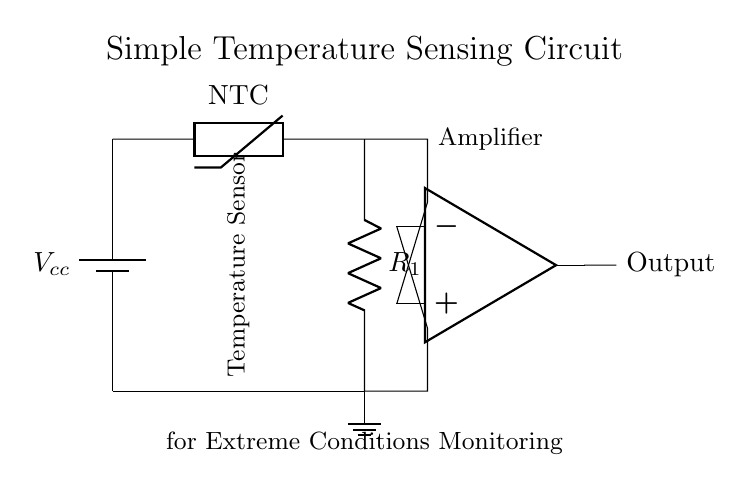What type of temperature sensor is used in this circuit? The circuit uses an NTC thermistor as the temperature sensor, indicated by the label on the component within the diagram.
Answer: NTC thermistor What does the op-amp do in this circuit? The operational amplifier (op-amp) amplifies the voltage difference between its input terminals, providing a stronger output signal that corresponds to the temperature reading.
Answer: Amplifies signal What is the configuration of the thermistor with the resistor in this circuit? The thermistor is configured in a voltage divider arrangement with the resistor, which allows for a change in voltage output relative to temperature changes detected by the thermistor.
Answer: Voltage divider What is the purpose of the battery in this circuit? The battery provides the necessary voltage supply for the circuit components, ensuring they operate correctly during temperature sensing.
Answer: Power supply What happens to the output as the temperature increases? As the temperature increases, the resistance of the NTC thermistor decreases, resulting in a higher voltage at the op-amp input, leading to a higher output voltage.
Answer: Output increases What is the connection between the thermistor and the op-amp in this circuit? The thermistor is connected directly to the non-inverting input of the op-amp, providing a voltage signal that corresponds to the measured temperature, while the resistor provides a reference voltage at the inverting input.
Answer: Connected to op-amp inputs How many main components are present in the circuit? The main components in this circuit include a battery, a thermistor, a resistor, and an op-amp, totaling four distinct components for its operation.
Answer: Four components 